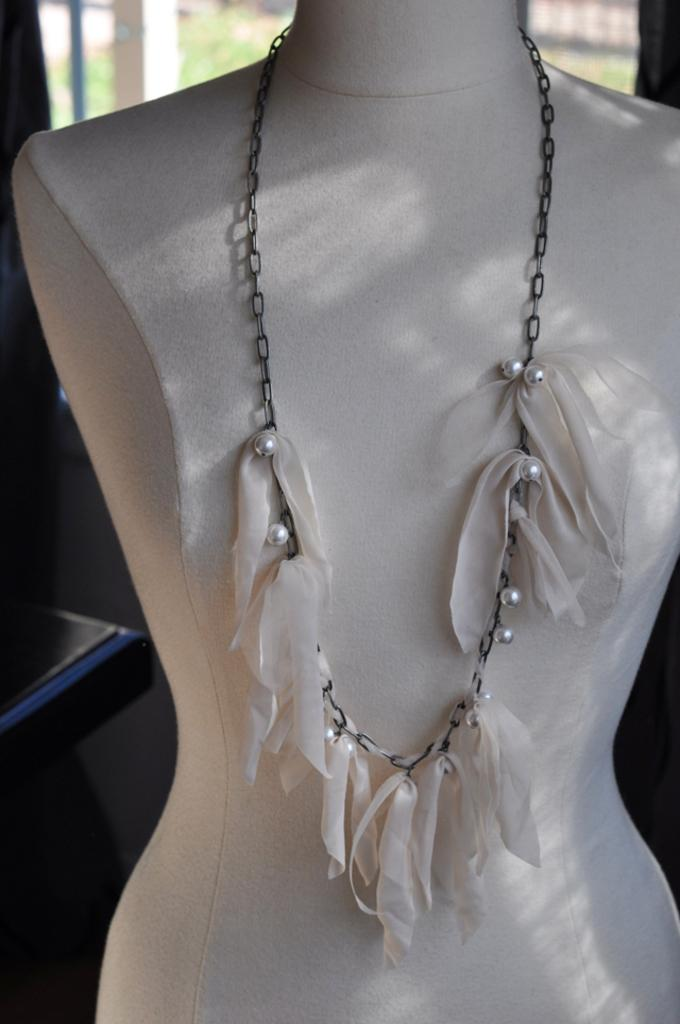What object can be seen in the image? There is a chain in the image. Where is the chain located? The chain is on a mannequin. What type of toys can be seen hanging from the chain in the image? There are no toys present in the image; it only features a chain on a mannequin. 